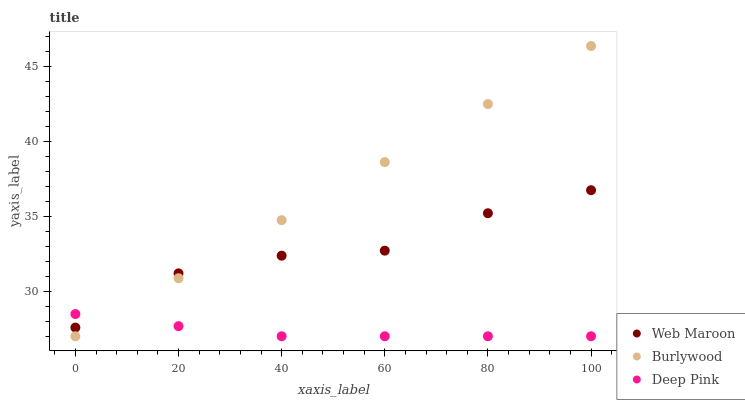Does Deep Pink have the minimum area under the curve?
Answer yes or no. Yes. Does Burlywood have the maximum area under the curve?
Answer yes or no. Yes. Does Web Maroon have the minimum area under the curve?
Answer yes or no. No. Does Web Maroon have the maximum area under the curve?
Answer yes or no. No. Is Burlywood the smoothest?
Answer yes or no. Yes. Is Web Maroon the roughest?
Answer yes or no. Yes. Is Deep Pink the smoothest?
Answer yes or no. No. Is Deep Pink the roughest?
Answer yes or no. No. Does Burlywood have the lowest value?
Answer yes or no. Yes. Does Web Maroon have the lowest value?
Answer yes or no. No. Does Burlywood have the highest value?
Answer yes or no. Yes. Does Web Maroon have the highest value?
Answer yes or no. No. Does Web Maroon intersect Burlywood?
Answer yes or no. Yes. Is Web Maroon less than Burlywood?
Answer yes or no. No. Is Web Maroon greater than Burlywood?
Answer yes or no. No. 